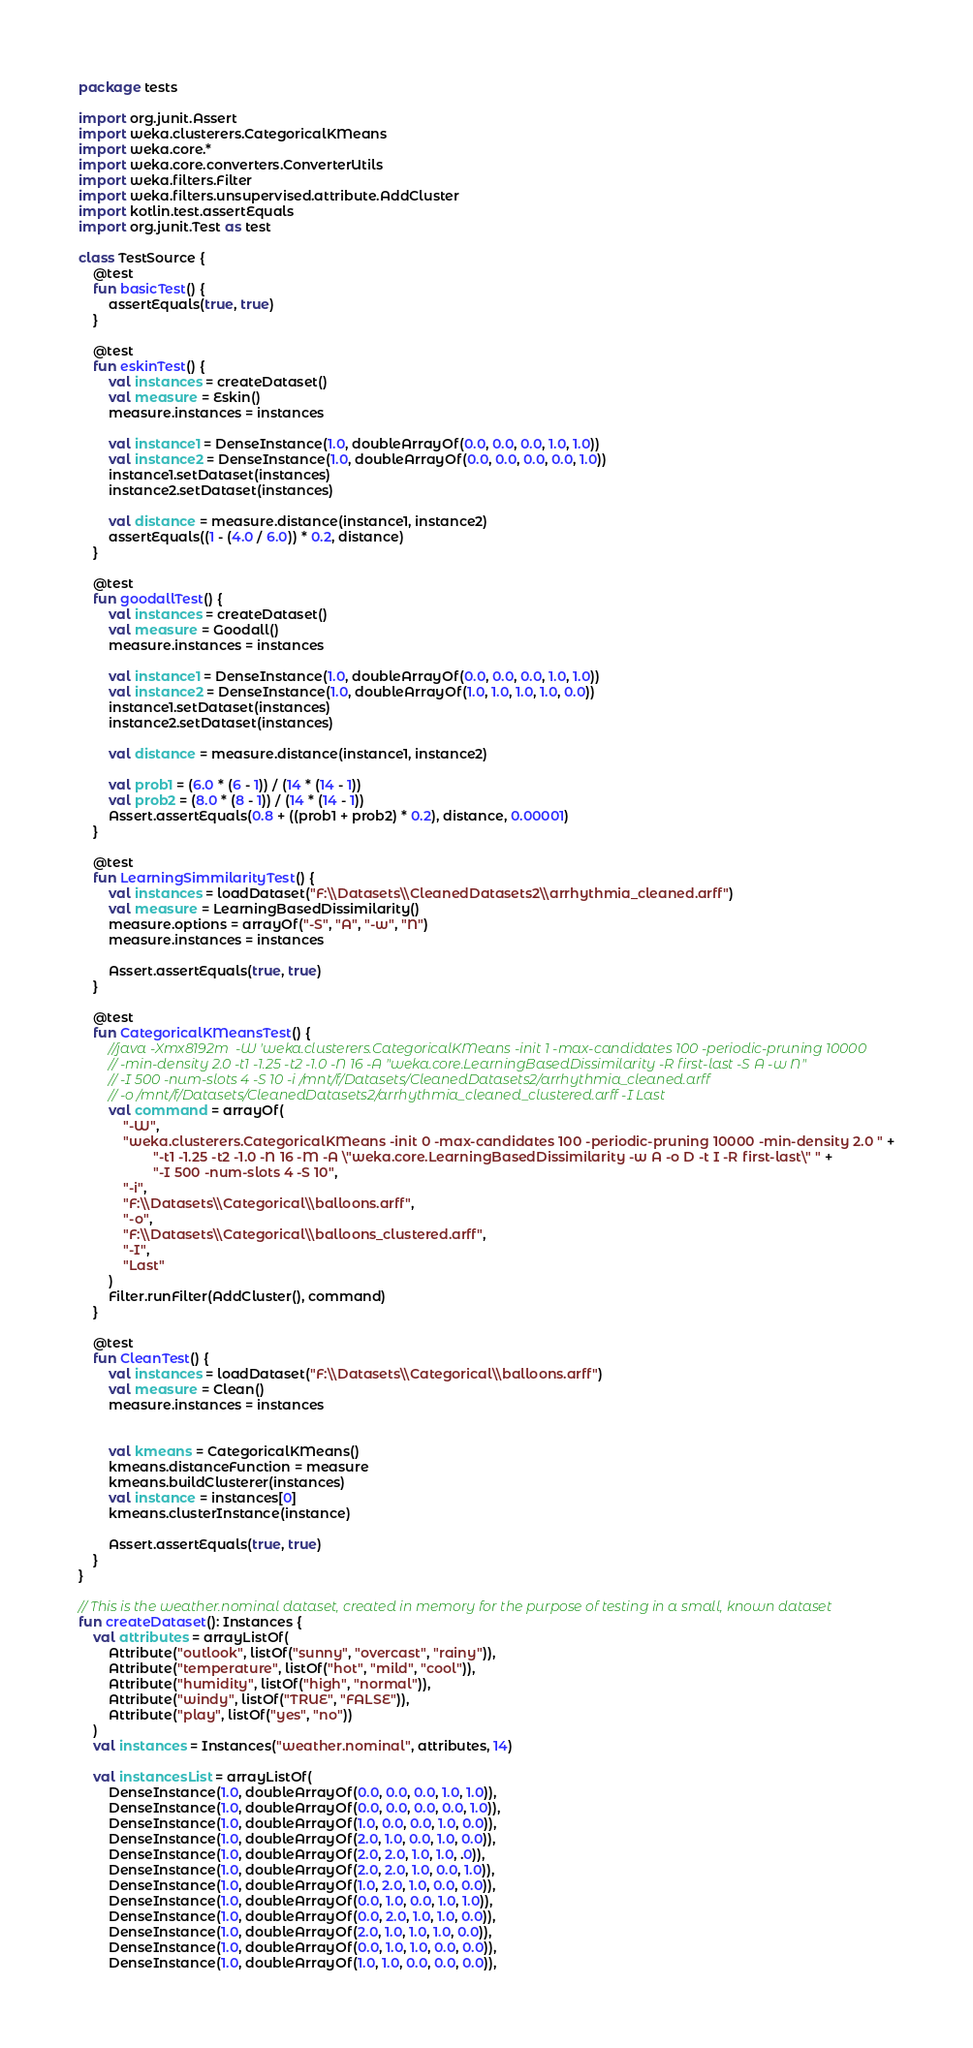<code> <loc_0><loc_0><loc_500><loc_500><_Kotlin_>package tests

import org.junit.Assert
import weka.clusterers.CategoricalKMeans
import weka.core.*
import weka.core.converters.ConverterUtils
import weka.filters.Filter
import weka.filters.unsupervised.attribute.AddCluster
import kotlin.test.assertEquals
import org.junit.Test as test

class TestSource {
    @test
    fun basicTest() {
        assertEquals(true, true)
    }

    @test
    fun eskinTest() {
        val instances = createDataset()
        val measure = Eskin()
        measure.instances = instances

        val instance1 = DenseInstance(1.0, doubleArrayOf(0.0, 0.0, 0.0, 1.0, 1.0))
        val instance2 = DenseInstance(1.0, doubleArrayOf(0.0, 0.0, 0.0, 0.0, 1.0))
        instance1.setDataset(instances)
        instance2.setDataset(instances)

        val distance = measure.distance(instance1, instance2)
        assertEquals((1 - (4.0 / 6.0)) * 0.2, distance)
    }

    @test
    fun goodallTest() {
        val instances = createDataset()
        val measure = Goodall()
        measure.instances = instances

        val instance1 = DenseInstance(1.0, doubleArrayOf(0.0, 0.0, 0.0, 1.0, 1.0))
        val instance2 = DenseInstance(1.0, doubleArrayOf(1.0, 1.0, 1.0, 1.0, 0.0))
        instance1.setDataset(instances)
        instance2.setDataset(instances)

        val distance = measure.distance(instance1, instance2)

        val prob1 = (6.0 * (6 - 1)) / (14 * (14 - 1))
        val prob2 = (8.0 * (8 - 1)) / (14 * (14 - 1))
        Assert.assertEquals(0.8 + ((prob1 + prob2) * 0.2), distance, 0.00001)
    }

    @test
    fun LearningSimmilarityTest() {
        val instances = loadDataset("F:\\Datasets\\CleanedDatasets2\\arrhythmia_cleaned.arff")
        val measure = LearningBasedDissimilarity()
        measure.options = arrayOf("-S", "A", "-w", "N")
        measure.instances = instances

        Assert.assertEquals(true, true)
    }

    @test
    fun CategoricalKMeansTest() {
        //java -Xmx8192m  -W 'weka.clusterers.CategoricalKMeans -init 1 -max-candidates 100 -periodic-pruning 10000
        // -min-density 2.0 -t1 -1.25 -t2 -1.0 -N 16 -A "weka.core.LearningBasedDissimilarity -R first-last -S A -w N"
        // -I 500 -num-slots 4 -S 10 -i /mnt/f/Datasets/CleanedDatasets2/arrhythmia_cleaned.arff
        // -o /mnt/f/Datasets/CleanedDatasets2/arrhythmia_cleaned_clustered.arff -I Last
        val command = arrayOf(
            "-W",
            "weka.clusterers.CategoricalKMeans -init 0 -max-candidates 100 -periodic-pruning 10000 -min-density 2.0 " +
                    "-t1 -1.25 -t2 -1.0 -N 16 -M -A \"weka.core.LearningBasedDissimilarity -w A -o D -t I -R first-last\" " +
                    "-I 500 -num-slots 4 -S 10",
            "-i",
            "F:\\Datasets\\Categorical\\balloons.arff",
            "-o",
            "F:\\Datasets\\Categorical\\balloons_clustered.arff",
            "-I",
            "Last"
        )
        Filter.runFilter(AddCluster(), command)
    }

    @test
    fun CleanTest() {
        val instances = loadDataset("F:\\Datasets\\Categorical\\balloons.arff")
        val measure = Clean()
        measure.instances = instances


        val kmeans = CategoricalKMeans()
        kmeans.distanceFunction = measure
        kmeans.buildClusterer(instances)
        val instance = instances[0]
        kmeans.clusterInstance(instance)

        Assert.assertEquals(true, true)
    }
}

// This is the weather.nominal dataset, created in memory for the purpose of testing in a small, known dataset
fun createDataset(): Instances {
    val attributes = arrayListOf(
        Attribute("outlook", listOf("sunny", "overcast", "rainy")),
        Attribute("temperature", listOf("hot", "mild", "cool")),
        Attribute("humidity", listOf("high", "normal")),
        Attribute("windy", listOf("TRUE", "FALSE")),
        Attribute("play", listOf("yes", "no"))
    )
    val instances = Instances("weather.nominal", attributes, 14)

    val instancesList = arrayListOf(
        DenseInstance(1.0, doubleArrayOf(0.0, 0.0, 0.0, 1.0, 1.0)),
        DenseInstance(1.0, doubleArrayOf(0.0, 0.0, 0.0, 0.0, 1.0)),
        DenseInstance(1.0, doubleArrayOf(1.0, 0.0, 0.0, 1.0, 0.0)),
        DenseInstance(1.0, doubleArrayOf(2.0, 1.0, 0.0, 1.0, 0.0)),
        DenseInstance(1.0, doubleArrayOf(2.0, 2.0, 1.0, 1.0, .0)),
        DenseInstance(1.0, doubleArrayOf(2.0, 2.0, 1.0, 0.0, 1.0)),
        DenseInstance(1.0, doubleArrayOf(1.0, 2.0, 1.0, 0.0, 0.0)),
        DenseInstance(1.0, doubleArrayOf(0.0, 1.0, 0.0, 1.0, 1.0)),
        DenseInstance(1.0, doubleArrayOf(0.0, 2.0, 1.0, 1.0, 0.0)),
        DenseInstance(1.0, doubleArrayOf(2.0, 1.0, 1.0, 1.0, 0.0)),
        DenseInstance(1.0, doubleArrayOf(0.0, 1.0, 1.0, 0.0, 0.0)),
        DenseInstance(1.0, doubleArrayOf(1.0, 1.0, 0.0, 0.0, 0.0)),</code> 